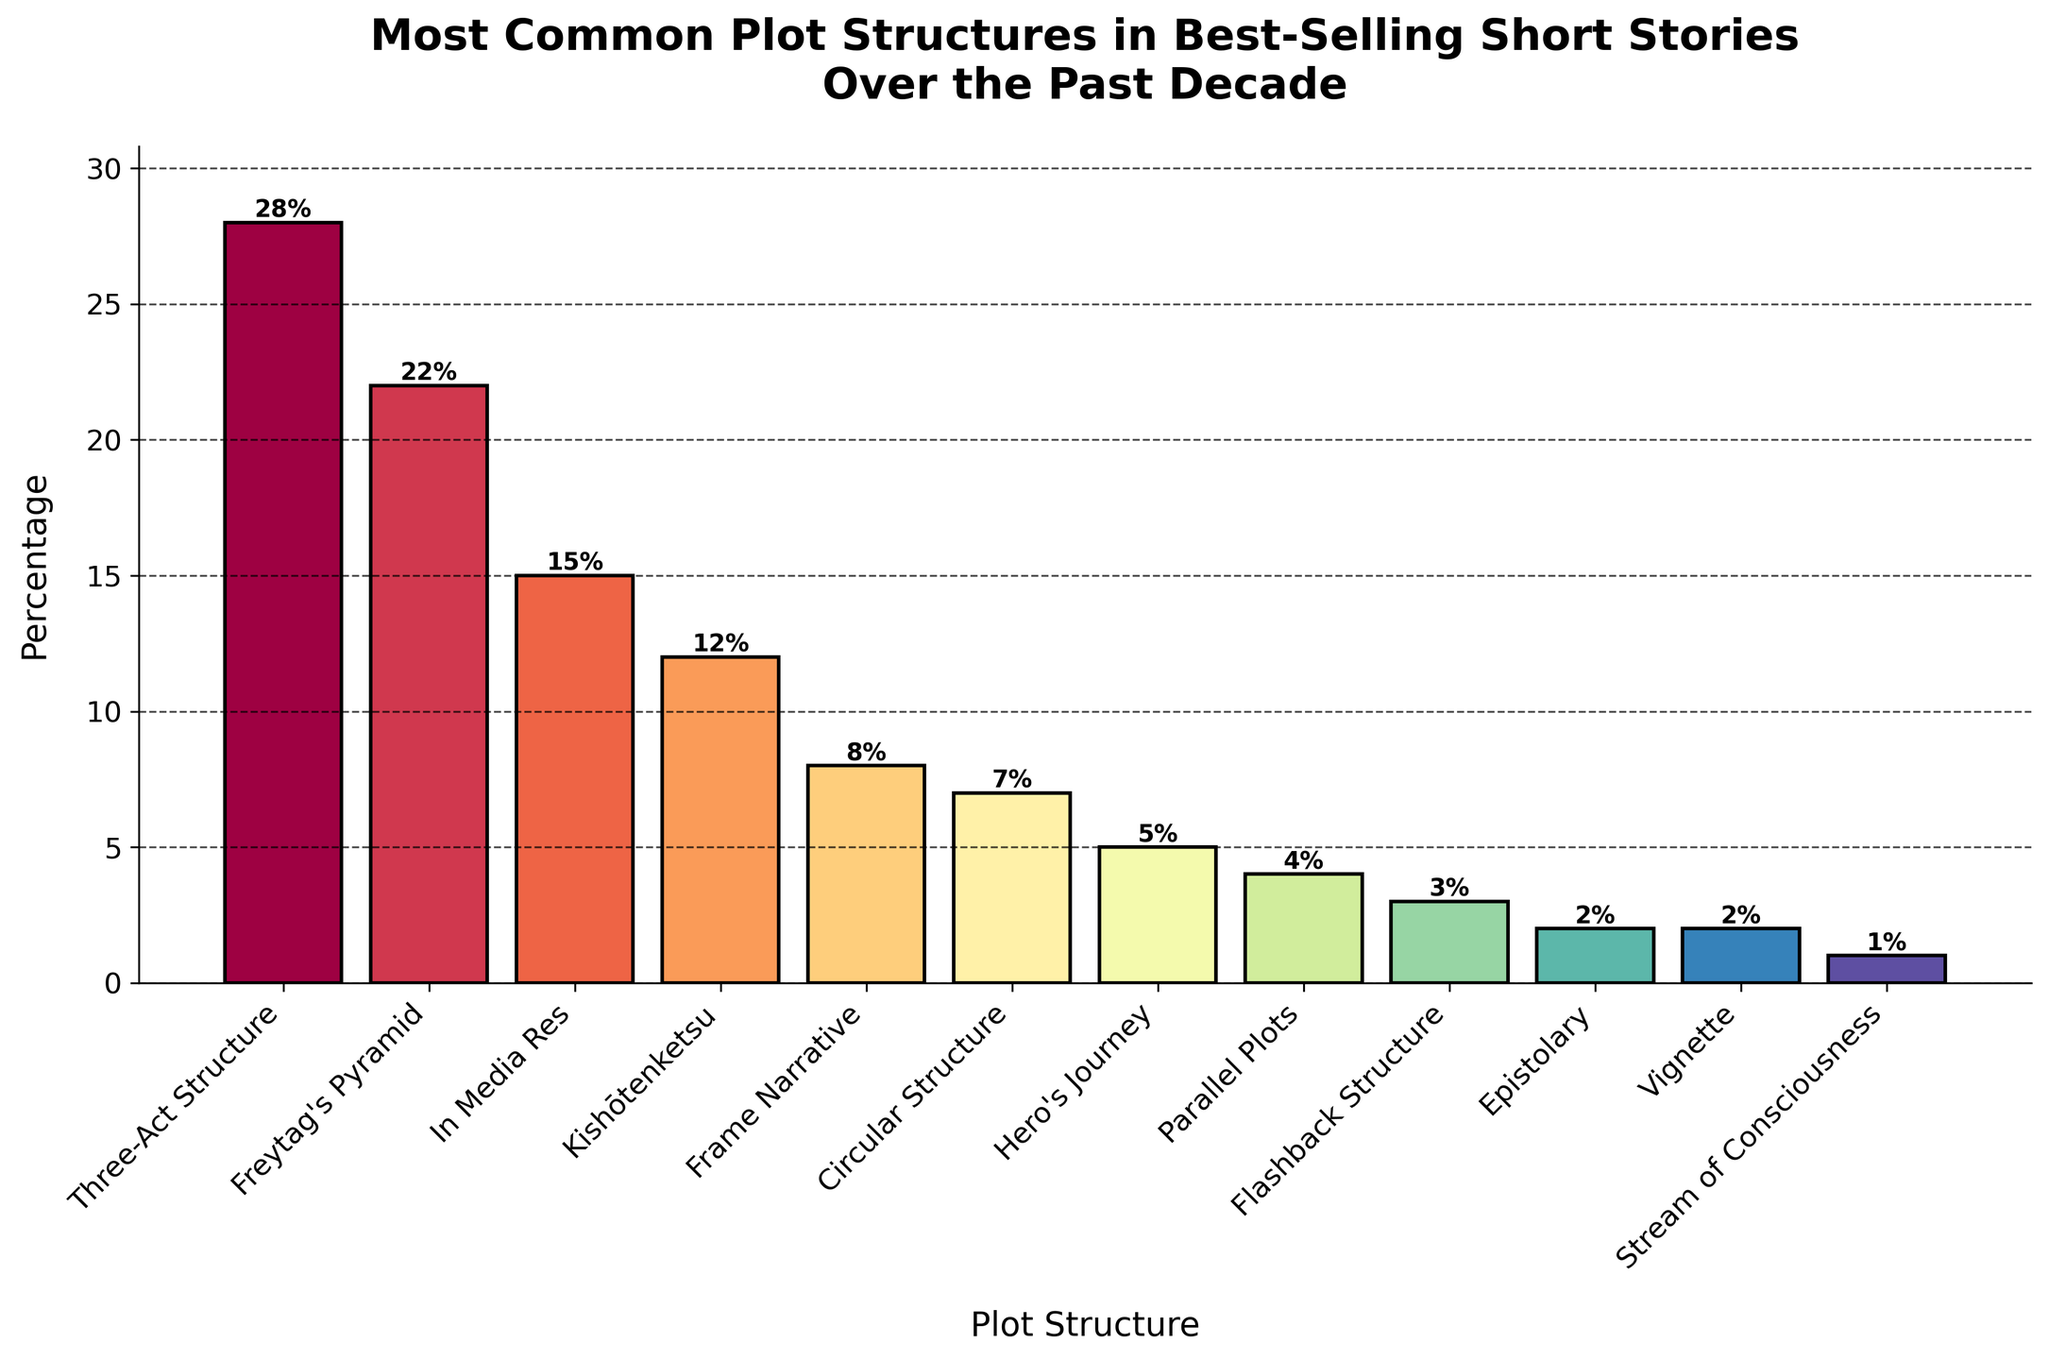Which plot structure is the most common in best-selling short stories over the past decade? Based on the height of the bars, the "Three-Act Structure" has the highest bar which indicates it is the most common plot structure.
Answer: Three-Act Structure What is the combined percentage of "Kishōtenketsu" and "Hero's Journey"? The percentages for "Kishōtenketsu" and "Hero's Journey" are 12% and 5% respectively. Adding them up gives 12 + 5 = 17.
Answer: 17% Which plot structure has the least representation in the best-selling short stories? The "Stream of Consciousness" plot structure has the shortest bar and is labeled with a percentage of 1%, indicating the least representation.
Answer: Stream of Consciousness How much higher is the percentage of "Freytag's Pyramid" compared to "Frame Narrative"? The percentage of "Freytag's Pyramid" is 22%, and for "Frame Narrative", it is 8%. Subtracting these gives 22 - 8 = 14.
Answer: 14% Which three plot structures have percentages greater than 20%? The plot structures with percentages greater than 20% are "Three-Act Structure" (28%), and "Freytag's Pyramid" (22%) as observed from their bar heights and values.
Answer: Three-Act Structure, Freytag's Pyramid What is the percentage difference between the most common and the least common plot structures? The "Three-Act Structure" is the most common with 28%, and the "Stream of Consciousness" is the least common with 1%. The difference is 28 - 1 = 27.
Answer: 27% How do the percentages of "In Media Res" and "Parallel Plots" compare? The percentage of "In Media Res" is 15%, while "Parallel Plots" is 4%. 15% is greater than 4%.
Answer: In Media Res > Parallel Plots Which plot structures have a representation of exactly 2%? The plot structures that have a bar height corresponding to 2% are "Epistolary" and "Vignette".
Answer: Epistolary, Vignette What is the total percentage of plot structures represented by "Frame Narrative", "Circular Structure", and "Flashback Structure"? Summing the percentages: "Frame Narrative" 8%, "Circular Structure" 7%, and "Flashback Structure" 3% gives 8 + 7 + 3 = 18.
Answer: 18% What is the average percentage representation for the plot structures "Hero's Journey" and "Stream of Consciousness"? Adding the percentages of "Hero's Journey" (5%) and "Stream of Consciousness" (1%) gives 5 + 1 = 6. Dividing by the number of plot structures (2) gives 6 / 2 = 3.
Answer: 3% 